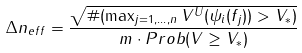<formula> <loc_0><loc_0><loc_500><loc_500>\Delta n _ { e f f } = \frac { \sqrt { \# ( \max _ { j = 1 , \dots , n } V ^ { U } ( { \psi _ { i } ( f _ { j } ) } ) > V _ { * } ) } } { m \cdot { P r o b } ( V \geq V _ { * } ) }</formula> 